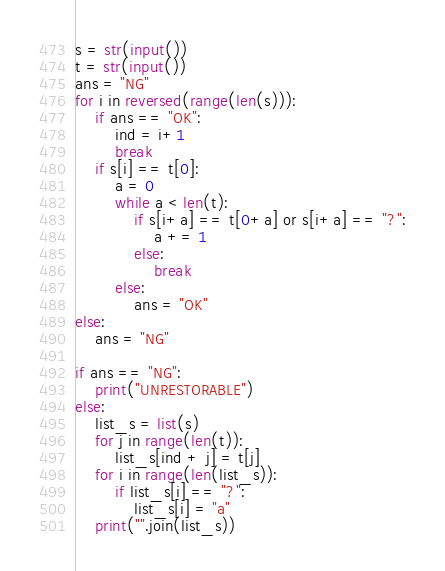<code> <loc_0><loc_0><loc_500><loc_500><_Python_>s = str(input())
t = str(input())
ans = "NG"
for i in reversed(range(len(s))):
    if ans == "OK":
        ind = i+1
        break
    if s[i] == t[0]:
        a = 0
        while a < len(t):
            if s[i+a] == t[0+a] or s[i+a] == "?":
                a += 1
            else:
                break
        else:
            ans = "OK"
else:
    ans = "NG"

if ans == "NG":
    print("UNRESTORABLE")
else:
    list_s = list(s)
    for j in range(len(t)):
        list_s[ind + j] = t[j]
    for i in range(len(list_s)):
        if list_s[i] == "?":
            list_s[i] = "a"
    print("".join(list_s))
</code> 